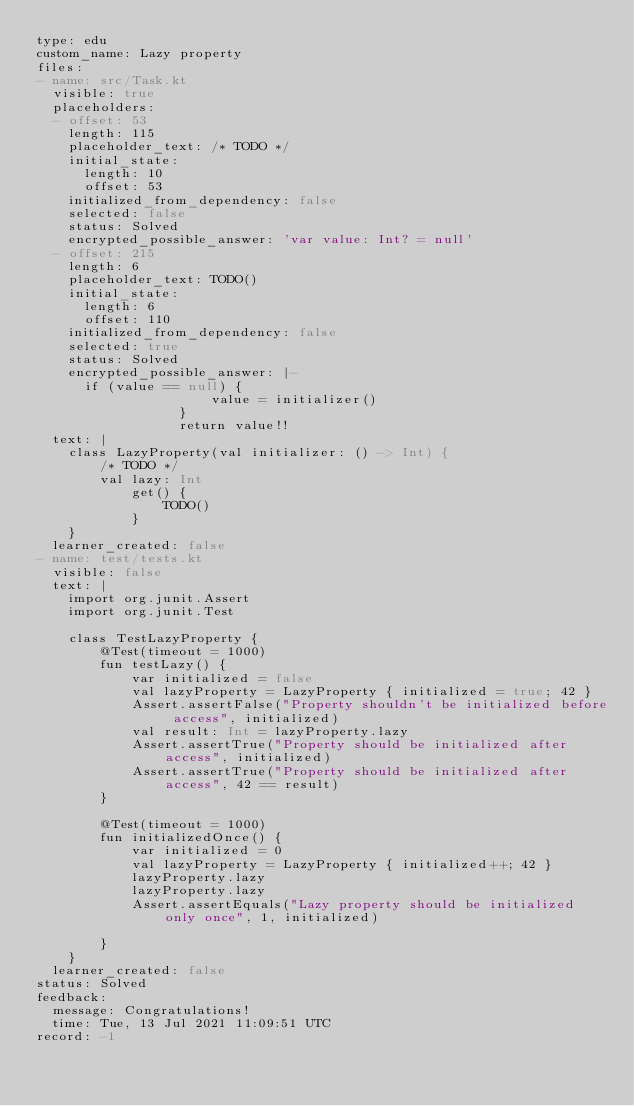Convert code to text. <code><loc_0><loc_0><loc_500><loc_500><_YAML_>type: edu
custom_name: Lazy property
files:
- name: src/Task.kt
  visible: true
  placeholders:
  - offset: 53
    length: 115
    placeholder_text: /* TODO */
    initial_state:
      length: 10
      offset: 53
    initialized_from_dependency: false
    selected: false
    status: Solved
    encrypted_possible_answer: 'var value: Int? = null'
  - offset: 215
    length: 6
    placeholder_text: TODO()
    initial_state:
      length: 6
      offset: 110
    initialized_from_dependency: false
    selected: true
    status: Solved
    encrypted_possible_answer: |-
      if (value == null) {
                      value = initializer()
                  }
                  return value!!
  text: |
    class LazyProperty(val initializer: () -> Int) {
        /* TODO */
        val lazy: Int
            get() {
                TODO()
            }
    }
  learner_created: false
- name: test/tests.kt
  visible: false
  text: |
    import org.junit.Assert
    import org.junit.Test

    class TestLazyProperty {
        @Test(timeout = 1000)
        fun testLazy() {
            var initialized = false
            val lazyProperty = LazyProperty { initialized = true; 42 }
            Assert.assertFalse("Property shouldn't be initialized before access", initialized)
            val result: Int = lazyProperty.lazy
            Assert.assertTrue("Property should be initialized after access", initialized)
            Assert.assertTrue("Property should be initialized after access", 42 == result)
        }

        @Test(timeout = 1000)
        fun initializedOnce() {
            var initialized = 0
            val lazyProperty = LazyProperty { initialized++; 42 }
            lazyProperty.lazy
            lazyProperty.lazy
            Assert.assertEquals("Lazy property should be initialized only once", 1, initialized)

        }
    }
  learner_created: false
status: Solved
feedback:
  message: Congratulations!
  time: Tue, 13 Jul 2021 11:09:51 UTC
record: -1
</code> 